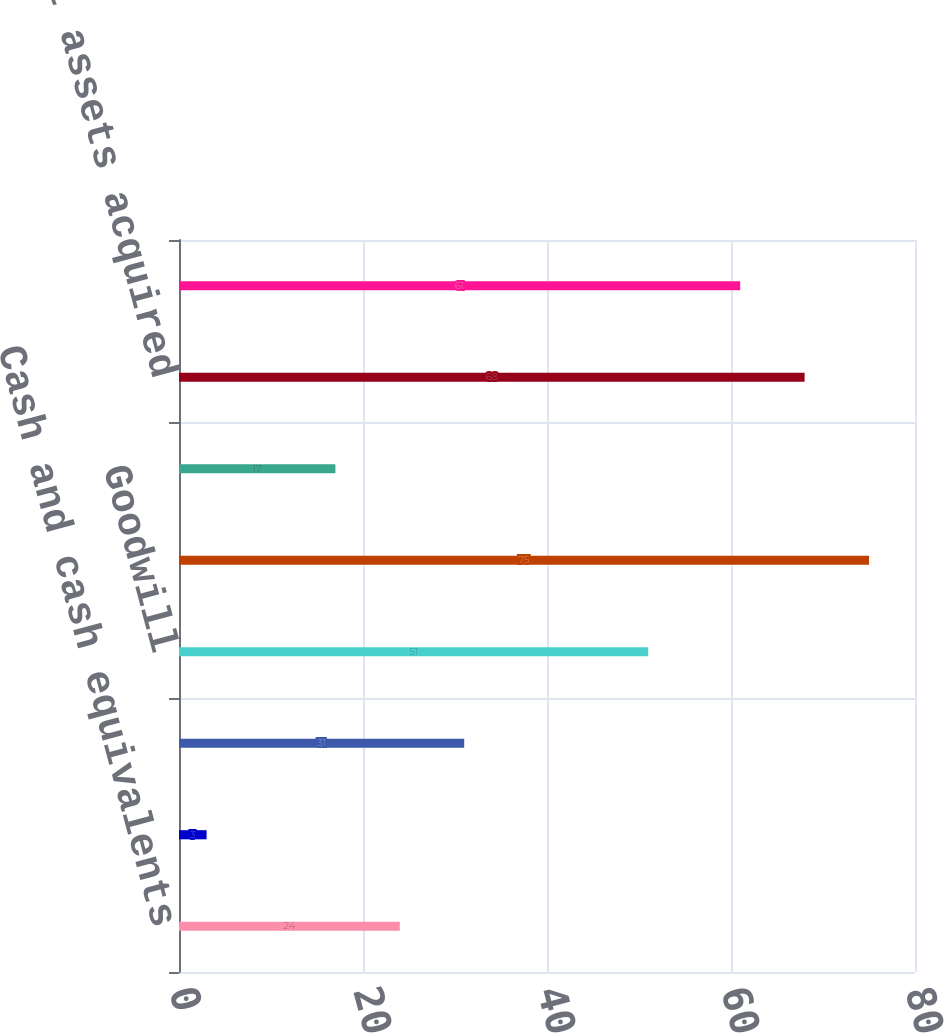Convert chart. <chart><loc_0><loc_0><loc_500><loc_500><bar_chart><fcel>Cash and cash equivalents<fcel>Tangible and other assets<fcel>Intangible assets<fcel>Goodwill<fcel>Total assets acquired<fcel>Liabilities assumed<fcel>Net assets acquired<fcel>Net cash paid<nl><fcel>24<fcel>3<fcel>31<fcel>51<fcel>75<fcel>17<fcel>68<fcel>61<nl></chart> 